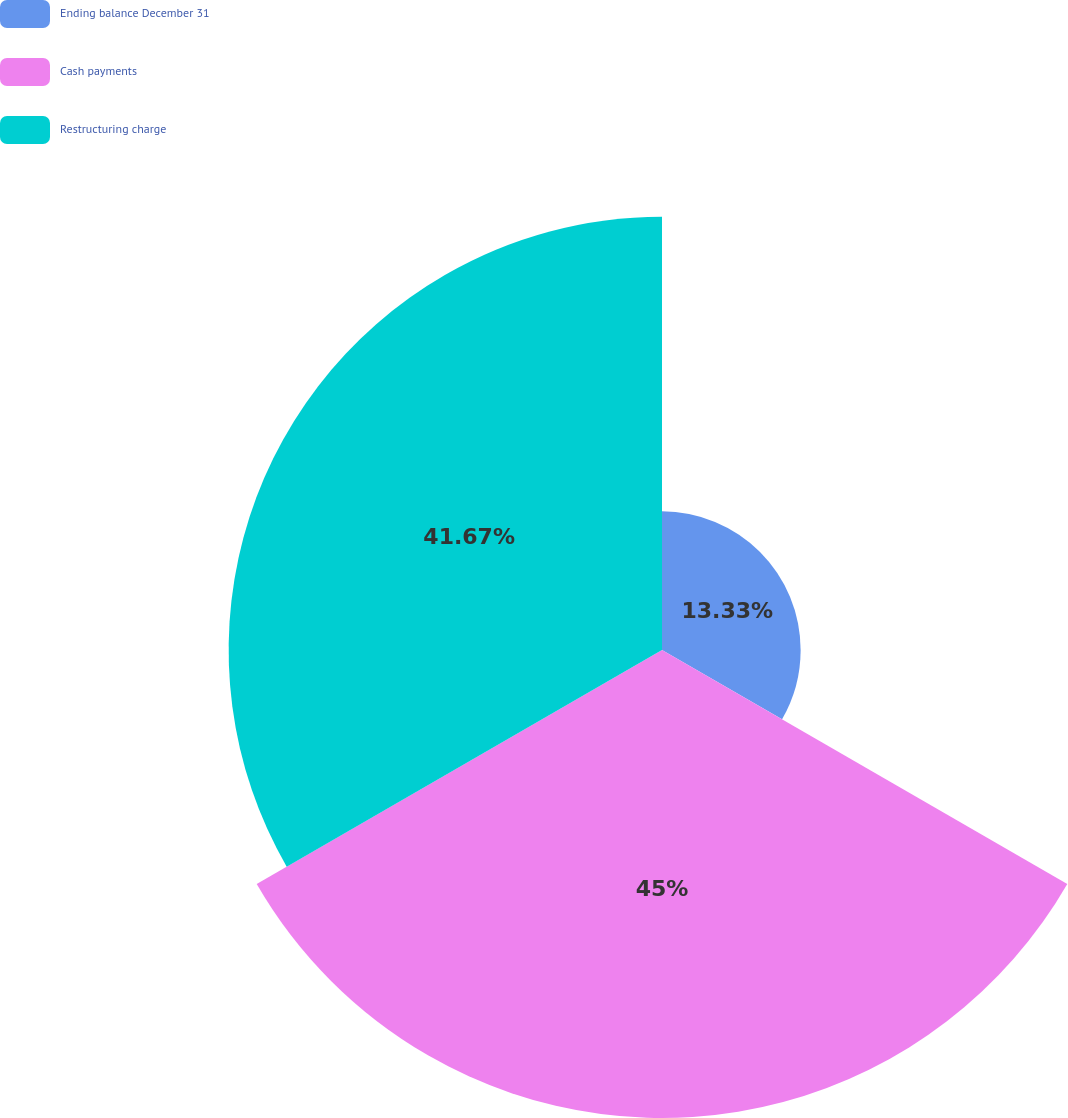Convert chart to OTSL. <chart><loc_0><loc_0><loc_500><loc_500><pie_chart><fcel>Ending balance December 31<fcel>Cash payments<fcel>Restructuring charge<nl><fcel>13.33%<fcel>45.0%<fcel>41.67%<nl></chart> 